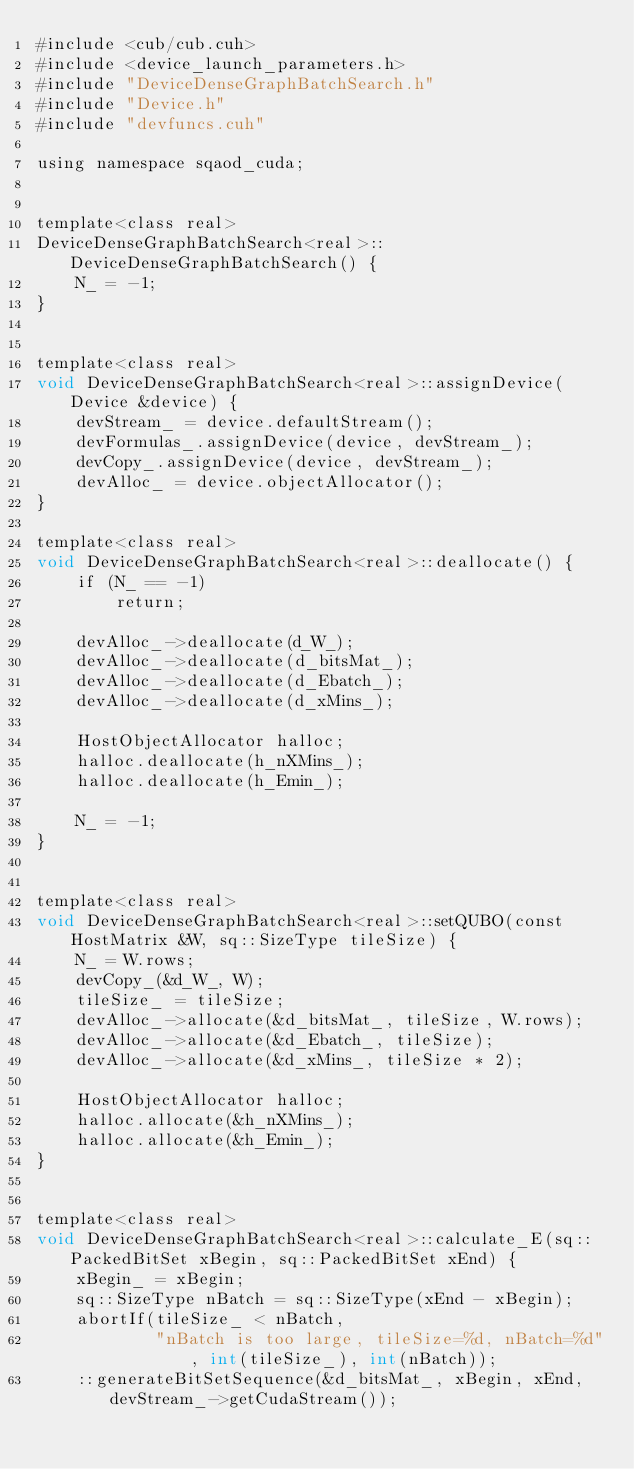<code> <loc_0><loc_0><loc_500><loc_500><_Cuda_>#include <cub/cub.cuh>
#include <device_launch_parameters.h>
#include "DeviceDenseGraphBatchSearch.h"
#include "Device.h"
#include "devfuncs.cuh"

using namespace sqaod_cuda;


template<class real>
DeviceDenseGraphBatchSearch<real>::DeviceDenseGraphBatchSearch() {
    N_ = -1;
}


template<class real>
void DeviceDenseGraphBatchSearch<real>::assignDevice(Device &device) {
    devStream_ = device.defaultStream();
    devFormulas_.assignDevice(device, devStream_);
    devCopy_.assignDevice(device, devStream_);
    devAlloc_ = device.objectAllocator();
}

template<class real>
void DeviceDenseGraphBatchSearch<real>::deallocate() {
    if (N_ == -1)
        return;

    devAlloc_->deallocate(d_W_);
    devAlloc_->deallocate(d_bitsMat_);
    devAlloc_->deallocate(d_Ebatch_);
    devAlloc_->deallocate(d_xMins_);

    HostObjectAllocator halloc;
    halloc.deallocate(h_nXMins_);
    halloc.deallocate(h_Emin_);

    N_ = -1;
}


template<class real>
void DeviceDenseGraphBatchSearch<real>::setQUBO(const HostMatrix &W, sq::SizeType tileSize) {
    N_ = W.rows;
    devCopy_(&d_W_, W);
    tileSize_ = tileSize;
    devAlloc_->allocate(&d_bitsMat_, tileSize, W.rows);
    devAlloc_->allocate(&d_Ebatch_, tileSize);
    devAlloc_->allocate(&d_xMins_, tileSize * 2);

    HostObjectAllocator halloc;
    halloc.allocate(&h_nXMins_);
    halloc.allocate(&h_Emin_);
}


template<class real>
void DeviceDenseGraphBatchSearch<real>::calculate_E(sq::PackedBitSet xBegin, sq::PackedBitSet xEnd) {
    xBegin_ = xBegin;
    sq::SizeType nBatch = sq::SizeType(xEnd - xBegin);
    abortIf(tileSize_ < nBatch,
            "nBatch is too large, tileSize=%d, nBatch=%d", int(tileSize_), int(nBatch));
    ::generateBitSetSequence(&d_bitsMat_, xBegin, xEnd, devStream_->getCudaStream());</code> 